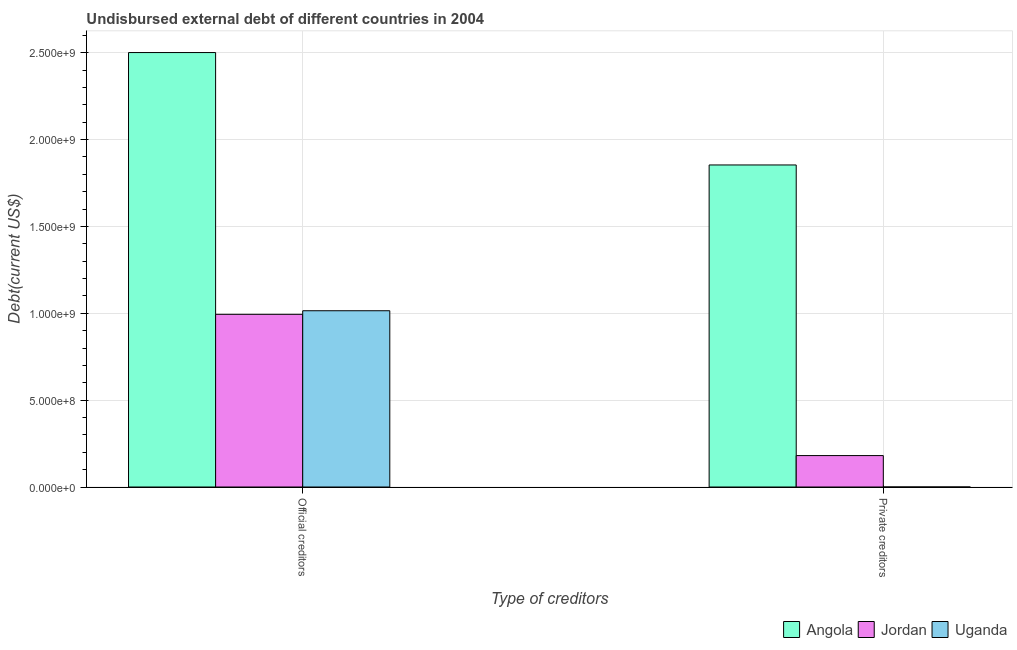How many groups of bars are there?
Offer a very short reply. 2. Are the number of bars per tick equal to the number of legend labels?
Provide a short and direct response. Yes. Are the number of bars on each tick of the X-axis equal?
Your answer should be compact. Yes. How many bars are there on the 1st tick from the right?
Ensure brevity in your answer.  3. What is the label of the 1st group of bars from the left?
Your answer should be compact. Official creditors. What is the undisbursed external debt of official creditors in Jordan?
Make the answer very short. 9.94e+08. Across all countries, what is the maximum undisbursed external debt of private creditors?
Give a very brief answer. 1.85e+09. Across all countries, what is the minimum undisbursed external debt of official creditors?
Keep it short and to the point. 9.94e+08. In which country was the undisbursed external debt of private creditors maximum?
Provide a short and direct response. Angola. In which country was the undisbursed external debt of private creditors minimum?
Provide a short and direct response. Uganda. What is the total undisbursed external debt of private creditors in the graph?
Your response must be concise. 2.03e+09. What is the difference between the undisbursed external debt of private creditors in Uganda and that in Angola?
Make the answer very short. -1.85e+09. What is the difference between the undisbursed external debt of official creditors in Jordan and the undisbursed external debt of private creditors in Uganda?
Ensure brevity in your answer.  9.94e+08. What is the average undisbursed external debt of official creditors per country?
Give a very brief answer. 1.50e+09. What is the difference between the undisbursed external debt of private creditors and undisbursed external debt of official creditors in Jordan?
Make the answer very short. -8.13e+08. What is the ratio of the undisbursed external debt of official creditors in Jordan to that in Angola?
Your answer should be compact. 0.4. What does the 2nd bar from the left in Official creditors represents?
Offer a terse response. Jordan. What does the 3rd bar from the right in Official creditors represents?
Ensure brevity in your answer.  Angola. How many bars are there?
Provide a short and direct response. 6. Are all the bars in the graph horizontal?
Ensure brevity in your answer.  No. How many countries are there in the graph?
Your answer should be very brief. 3. Are the values on the major ticks of Y-axis written in scientific E-notation?
Keep it short and to the point. Yes. Does the graph contain any zero values?
Ensure brevity in your answer.  No. Does the graph contain grids?
Ensure brevity in your answer.  Yes. Where does the legend appear in the graph?
Give a very brief answer. Bottom right. How many legend labels are there?
Your response must be concise. 3. How are the legend labels stacked?
Provide a short and direct response. Horizontal. What is the title of the graph?
Provide a short and direct response. Undisbursed external debt of different countries in 2004. What is the label or title of the X-axis?
Offer a terse response. Type of creditors. What is the label or title of the Y-axis?
Provide a succinct answer. Debt(current US$). What is the Debt(current US$) in Angola in Official creditors?
Offer a very short reply. 2.50e+09. What is the Debt(current US$) of Jordan in Official creditors?
Keep it short and to the point. 9.94e+08. What is the Debt(current US$) of Uganda in Official creditors?
Your answer should be compact. 1.01e+09. What is the Debt(current US$) in Angola in Private creditors?
Make the answer very short. 1.85e+09. What is the Debt(current US$) in Jordan in Private creditors?
Ensure brevity in your answer.  1.81e+08. What is the Debt(current US$) in Uganda in Private creditors?
Give a very brief answer. 2.50e+04. Across all Type of creditors, what is the maximum Debt(current US$) of Angola?
Offer a terse response. 2.50e+09. Across all Type of creditors, what is the maximum Debt(current US$) of Jordan?
Your answer should be very brief. 9.94e+08. Across all Type of creditors, what is the maximum Debt(current US$) of Uganda?
Provide a succinct answer. 1.01e+09. Across all Type of creditors, what is the minimum Debt(current US$) in Angola?
Ensure brevity in your answer.  1.85e+09. Across all Type of creditors, what is the minimum Debt(current US$) of Jordan?
Your response must be concise. 1.81e+08. Across all Type of creditors, what is the minimum Debt(current US$) of Uganda?
Provide a succinct answer. 2.50e+04. What is the total Debt(current US$) in Angola in the graph?
Give a very brief answer. 4.35e+09. What is the total Debt(current US$) in Jordan in the graph?
Ensure brevity in your answer.  1.17e+09. What is the total Debt(current US$) in Uganda in the graph?
Keep it short and to the point. 1.01e+09. What is the difference between the Debt(current US$) of Angola in Official creditors and that in Private creditors?
Your answer should be compact. 6.47e+08. What is the difference between the Debt(current US$) in Jordan in Official creditors and that in Private creditors?
Provide a succinct answer. 8.13e+08. What is the difference between the Debt(current US$) of Uganda in Official creditors and that in Private creditors?
Make the answer very short. 1.01e+09. What is the difference between the Debt(current US$) of Angola in Official creditors and the Debt(current US$) of Jordan in Private creditors?
Keep it short and to the point. 2.32e+09. What is the difference between the Debt(current US$) of Angola in Official creditors and the Debt(current US$) of Uganda in Private creditors?
Offer a very short reply. 2.50e+09. What is the difference between the Debt(current US$) of Jordan in Official creditors and the Debt(current US$) of Uganda in Private creditors?
Offer a terse response. 9.94e+08. What is the average Debt(current US$) of Angola per Type of creditors?
Make the answer very short. 2.18e+09. What is the average Debt(current US$) of Jordan per Type of creditors?
Make the answer very short. 5.87e+08. What is the average Debt(current US$) of Uganda per Type of creditors?
Make the answer very short. 5.07e+08. What is the difference between the Debt(current US$) in Angola and Debt(current US$) in Jordan in Official creditors?
Your answer should be very brief. 1.51e+09. What is the difference between the Debt(current US$) of Angola and Debt(current US$) of Uganda in Official creditors?
Provide a short and direct response. 1.49e+09. What is the difference between the Debt(current US$) of Jordan and Debt(current US$) of Uganda in Official creditors?
Your answer should be very brief. -2.06e+07. What is the difference between the Debt(current US$) in Angola and Debt(current US$) in Jordan in Private creditors?
Your answer should be very brief. 1.67e+09. What is the difference between the Debt(current US$) in Angola and Debt(current US$) in Uganda in Private creditors?
Your answer should be compact. 1.85e+09. What is the difference between the Debt(current US$) of Jordan and Debt(current US$) of Uganda in Private creditors?
Your answer should be compact. 1.81e+08. What is the ratio of the Debt(current US$) in Angola in Official creditors to that in Private creditors?
Ensure brevity in your answer.  1.35. What is the ratio of the Debt(current US$) of Jordan in Official creditors to that in Private creditors?
Your answer should be very brief. 5.49. What is the ratio of the Debt(current US$) of Uganda in Official creditors to that in Private creditors?
Give a very brief answer. 4.06e+04. What is the difference between the highest and the second highest Debt(current US$) of Angola?
Offer a very short reply. 6.47e+08. What is the difference between the highest and the second highest Debt(current US$) in Jordan?
Offer a very short reply. 8.13e+08. What is the difference between the highest and the second highest Debt(current US$) of Uganda?
Ensure brevity in your answer.  1.01e+09. What is the difference between the highest and the lowest Debt(current US$) of Angola?
Provide a short and direct response. 6.47e+08. What is the difference between the highest and the lowest Debt(current US$) in Jordan?
Your response must be concise. 8.13e+08. What is the difference between the highest and the lowest Debt(current US$) in Uganda?
Give a very brief answer. 1.01e+09. 